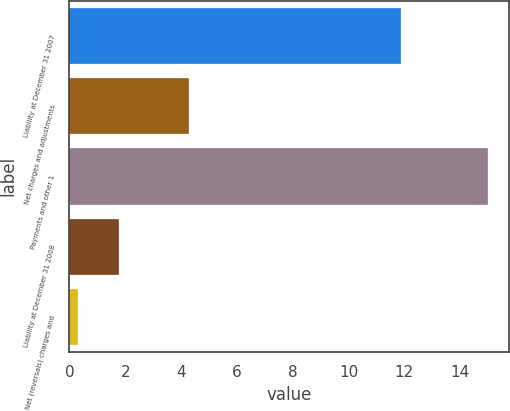Convert chart. <chart><loc_0><loc_0><loc_500><loc_500><bar_chart><fcel>Liability at December 31 2007<fcel>Net charges and adjustments<fcel>Payments and other 1<fcel>Liability at December 31 2008<fcel>Net (reversals) charges and<nl><fcel>11.9<fcel>4.3<fcel>15<fcel>1.77<fcel>0.3<nl></chart> 